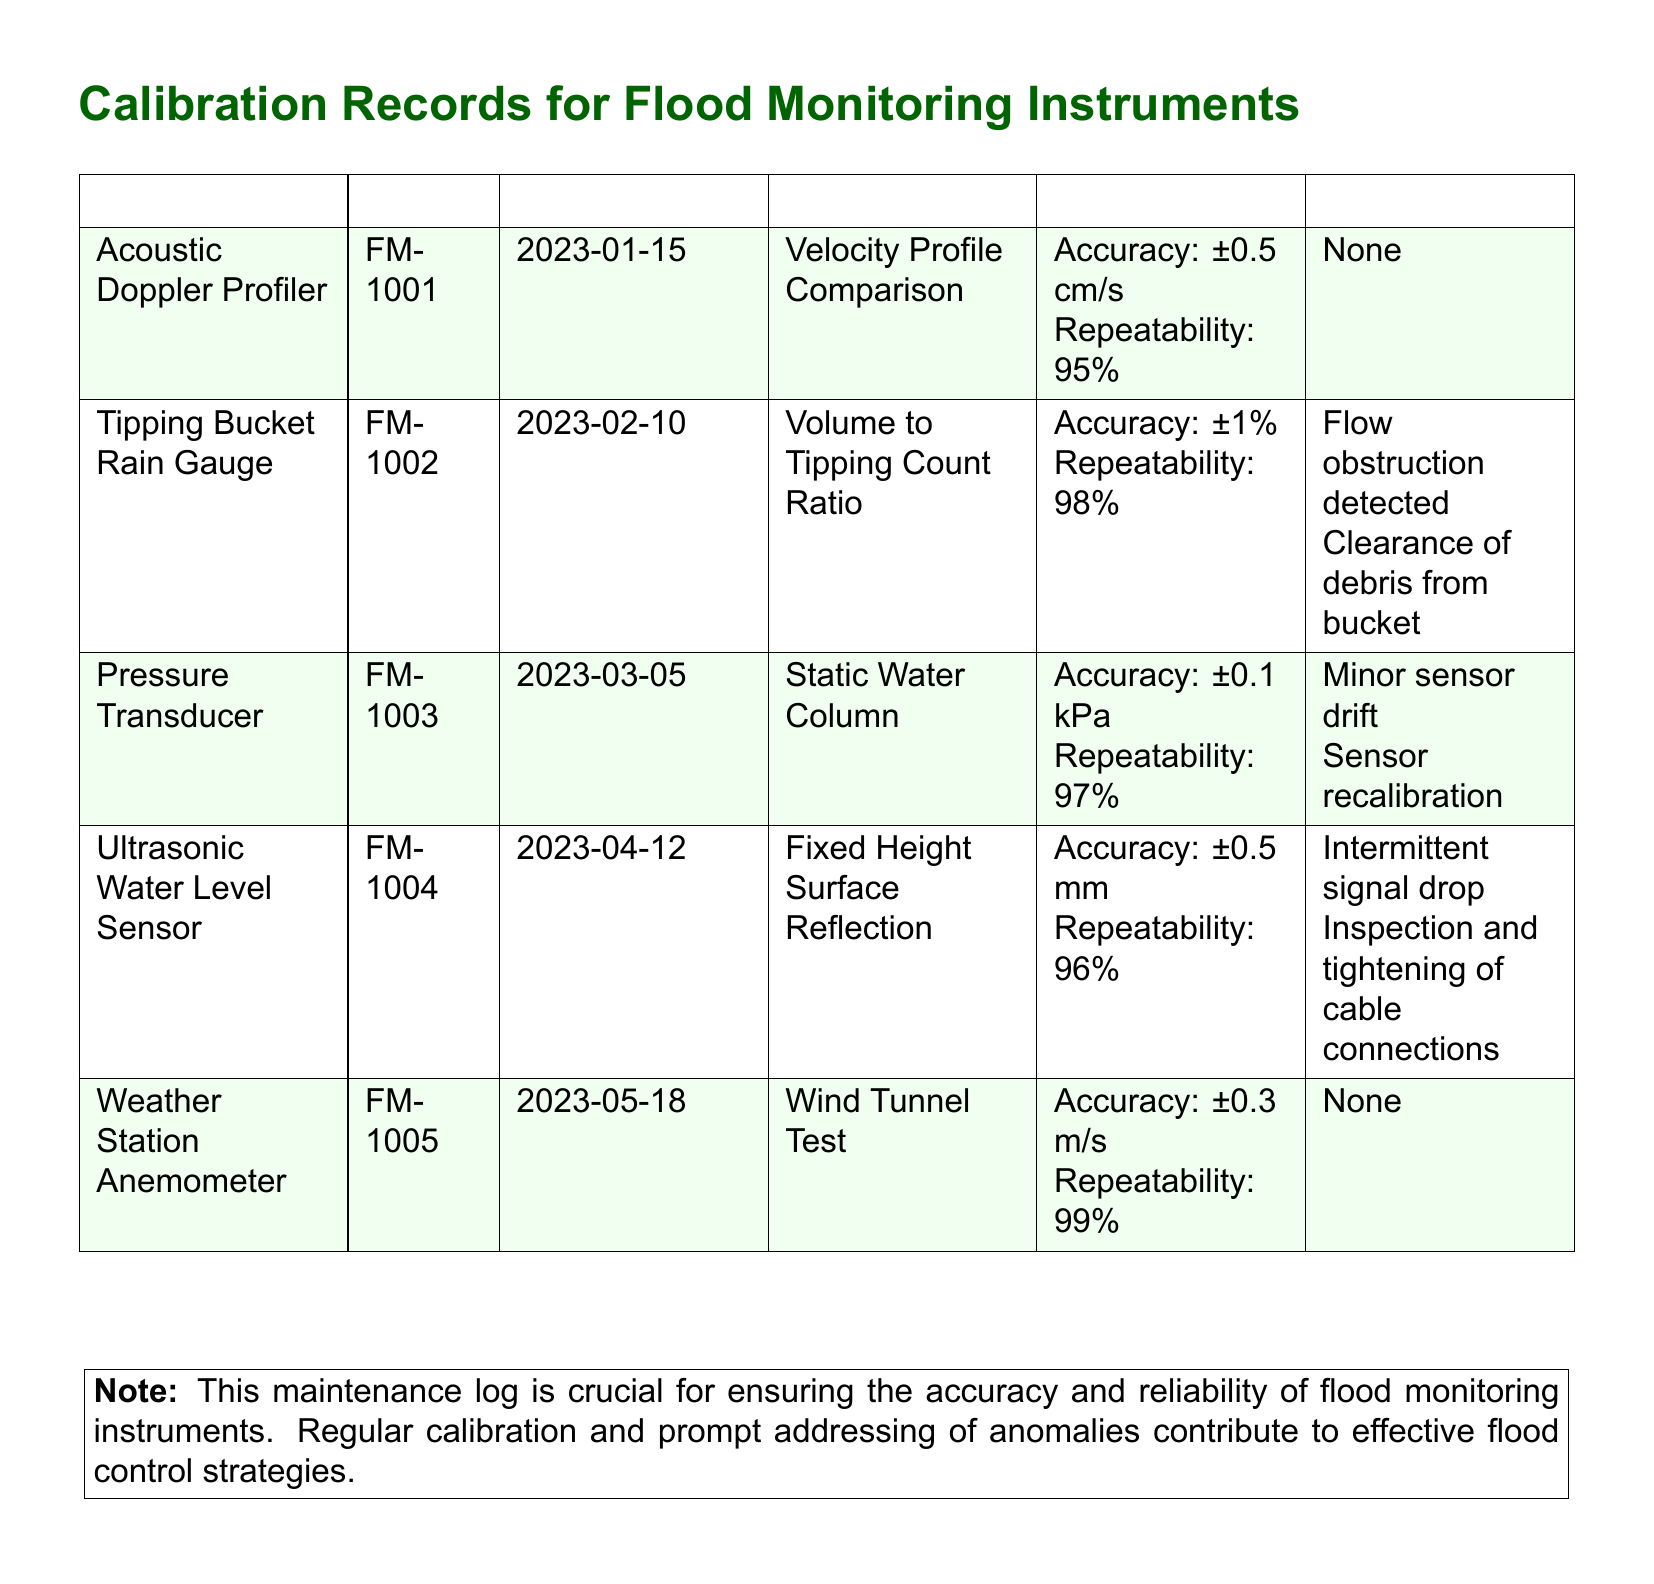What is the ID of the Acoustic Doppler Profiler? The ID can be found in the first column under the "ID" heading corresponding to the Acoustic Doppler Profiler entry.
Answer: FM-1001 When was the Tipping Bucket Rain Gauge last calibrated? The date of the last calibration is listed in the "Date" column for the Tipping Bucket Rain Gauge.
Answer: 2023-02-10 What method was used for the Pressure Transducer calibration? The method is specified in the "Method" column for the Pressure Transducer entry.
Answer: Static Water Column What was the accuracy result for the Ultrasonic Water Level Sensor? The accuracy result is stated in the "Results" column for the Ultrasonic Water Level Sensor.
Answer: ±0.5 mm Which instrument had a flow obstruction detected? The instrument with a flow obstruction detected is listed in the "Anomalies/Repairs" column for that specific instrument.
Answer: Tipping Bucket Rain Gauge How many instruments were calibrated in 2023? The number of instruments is determined by counting the entries in the document for the year 2023.
Answer: 5 What was required for the Pressure Transducer after detection of sensor drift? The required action is mentioned in the "Anomalies/Repairs" column for the Pressure Transducer.
Answer: Sensor recalibration Which instrument had the highest repeatability percentage? The highest repeatability percentage is deduced from the "Repeatability" results for all instruments.
Answer: Weather Station Anemometer What is the note regarding the maintenance log? The note can be found at the bottom of the document emphasizing the importance of regular calibration.
Answer: Crucial for ensuring accuracy and reliability 